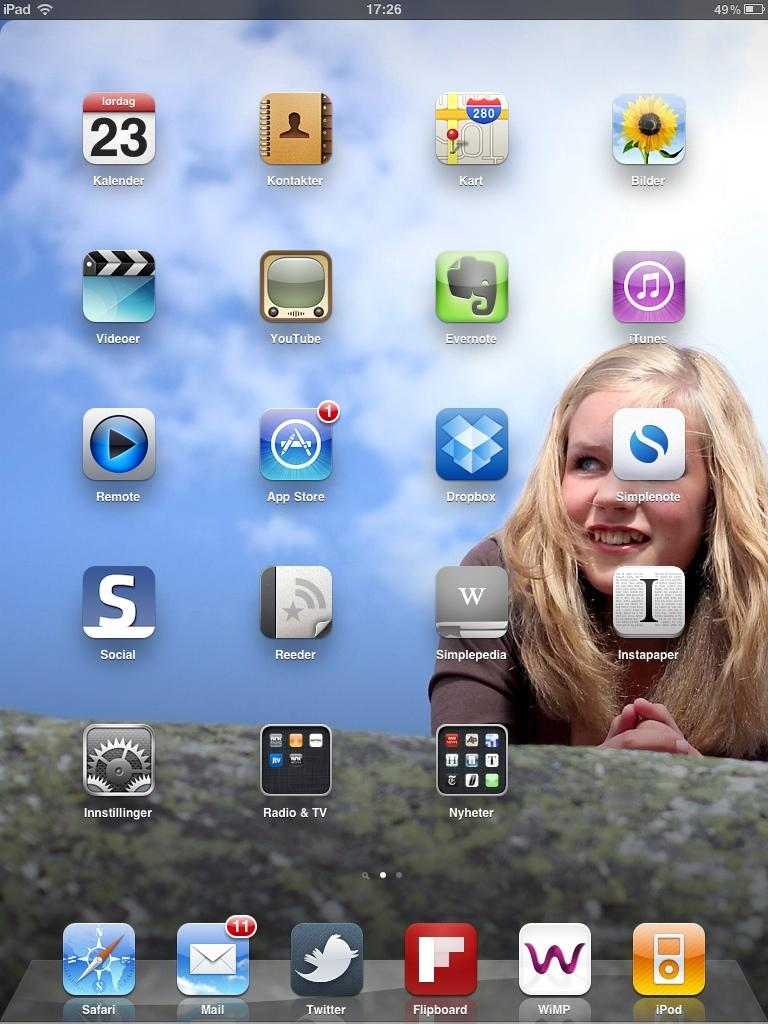<image>
Relay a brief, clear account of the picture shown. A tablet screen has a girl pictured and an icon that says Kalender. 